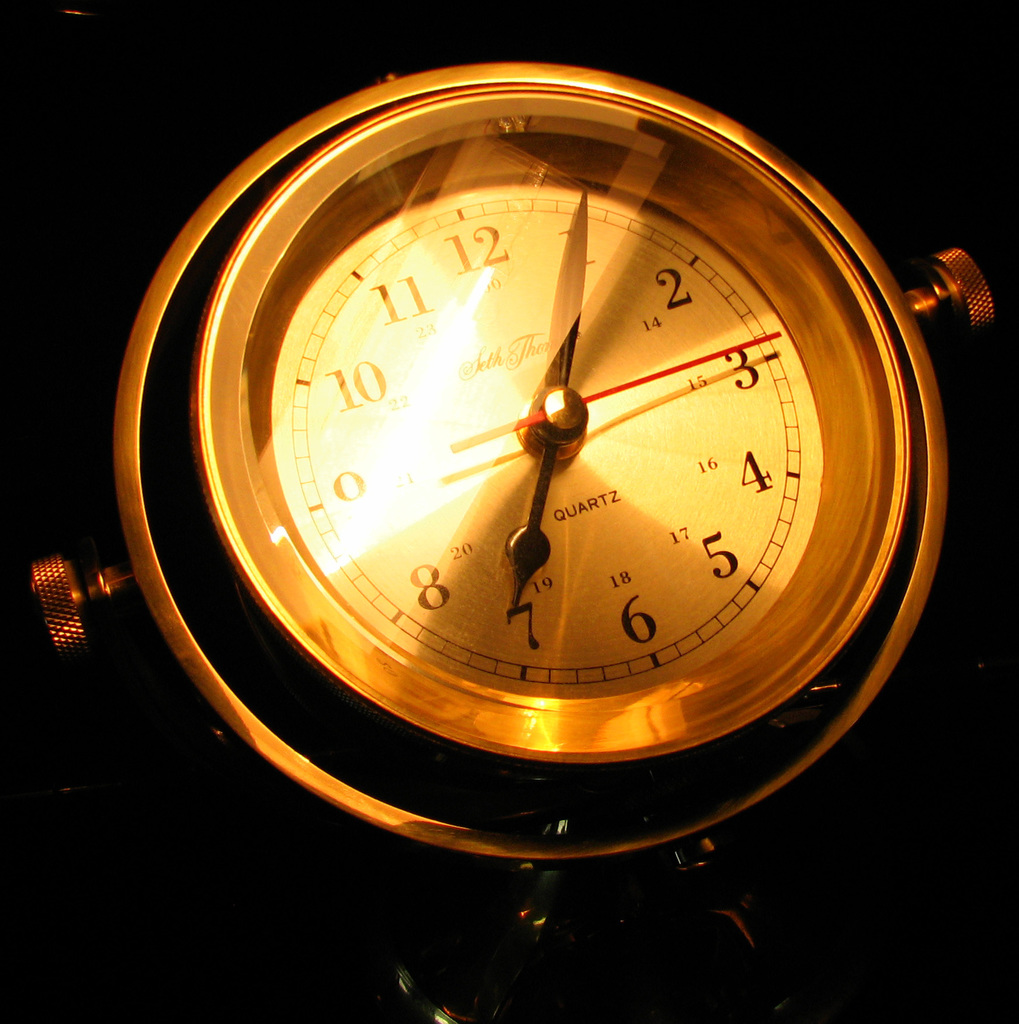What style of clock is displayed in the image, and can you tell if it has any special features? The image features a traditional wall clock, recognizable by its circular design and numbered face. Notably, it includes a quartz movement, revealed by the inscription on the dial, which is valued for keeping accurate time with minimal maintenance.  How does the lighting affect the appearance of the clock in the image? The warm, ambient lighting casts a soft glow on the gold-toned surface of the clock, accentuating its sleek and timeless design, and creating a cozy atmosphere that enhances the visual appeal of the clock. 